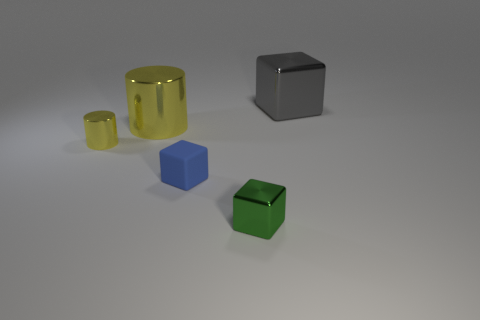Add 3 yellow metal things. How many objects exist? 8 Subtract all cubes. How many objects are left? 2 Subtract all tiny gray shiny cylinders. Subtract all tiny metal cylinders. How many objects are left? 4 Add 1 big gray blocks. How many big gray blocks are left? 2 Add 3 small cyan rubber balls. How many small cyan rubber balls exist? 3 Subtract 0 red cubes. How many objects are left? 5 